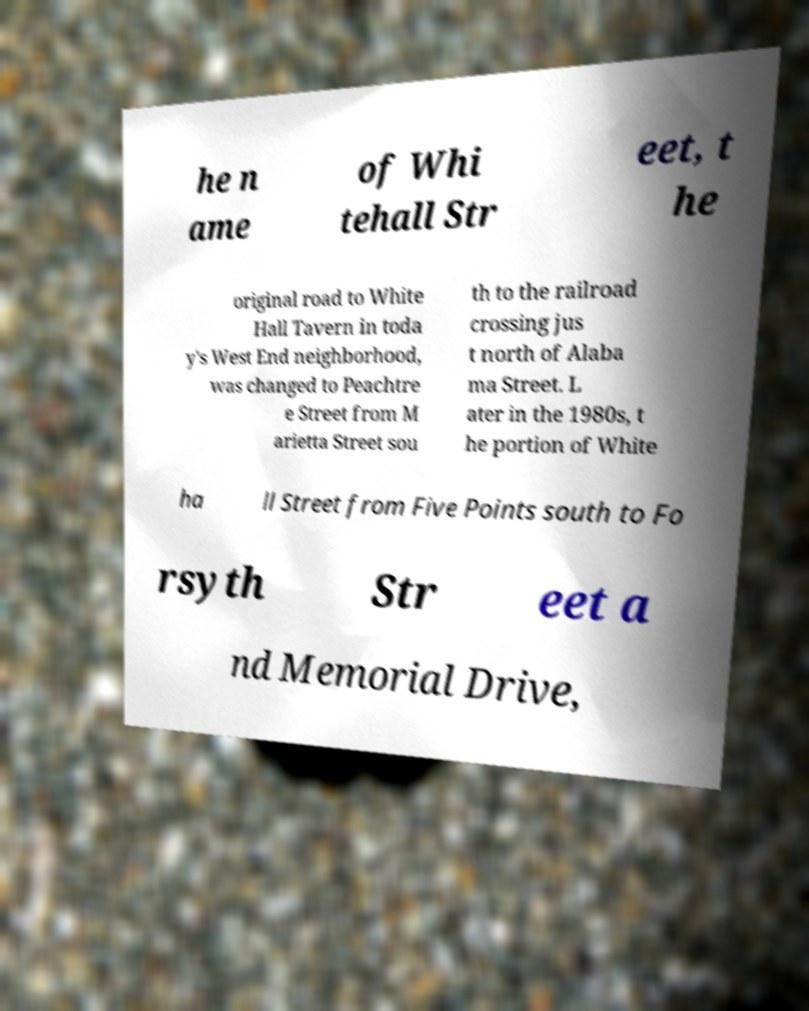Can you read and provide the text displayed in the image?This photo seems to have some interesting text. Can you extract and type it out for me? he n ame of Whi tehall Str eet, t he original road to White Hall Tavern in toda y's West End neighborhood, was changed to Peachtre e Street from M arietta Street sou th to the railroad crossing jus t north of Alaba ma Street. L ater in the 1980s, t he portion of White ha ll Street from Five Points south to Fo rsyth Str eet a nd Memorial Drive, 